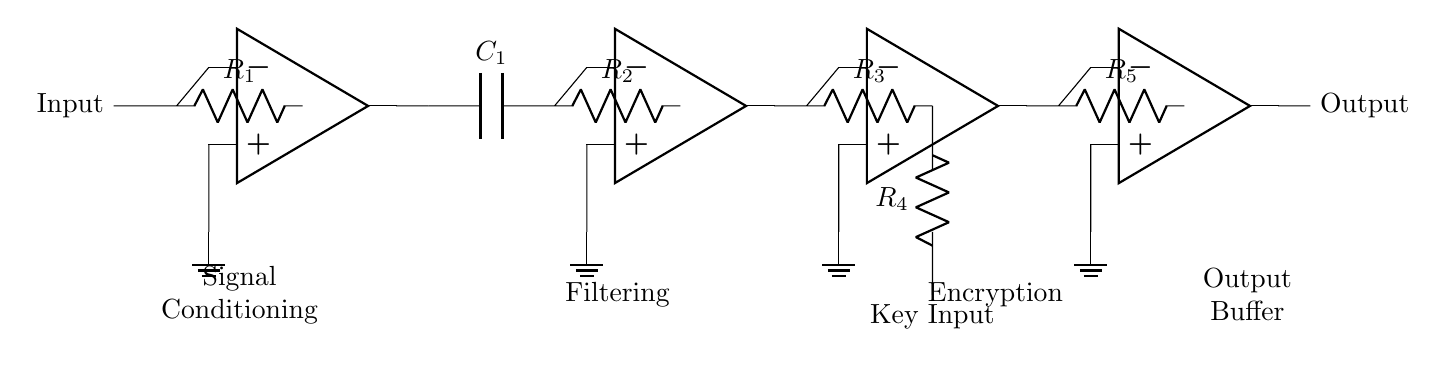What type of signal conditioning is represented in this circuit? The circuit employs op-amps for signal conditioning, indicating it's analog signal processing.
Answer: Analog How many operational amplifiers are used in this circuit? The diagram shows four operational amplifiers represented as op-amps in series, each performing a stage of processing.
Answer: Four What is the function of capacitor C1 in the circuit? Capacitor C1 is part of the filtering stage, intending to smooth out the signal by reducing high-frequency noise.
Answer: Filtering Which component is used for input keying in the encryption stage? The component used for key input is a resistor labeled R4, which connects to the encryption stage for signal manipulation based on a key.
Answer: Resistor What is the role of the output buffer in this circuit? The output buffer, using an op-amp, amplifies and provides the final processed signal for transmission, ensuring it drives the load effectively.
Answer: Buffering What happens to the signal after passing through R3? After R3, the signal enters the encryption stage with an op-amp, which modifies the signal based on the key input from R4 to enhance security.
Answer: Encryption What does node labeled "Output" indicate in the circuit? The node labeled "Output" shows where the final processed and conditioned signal is made available to exit the device for use.
Answer: Output 